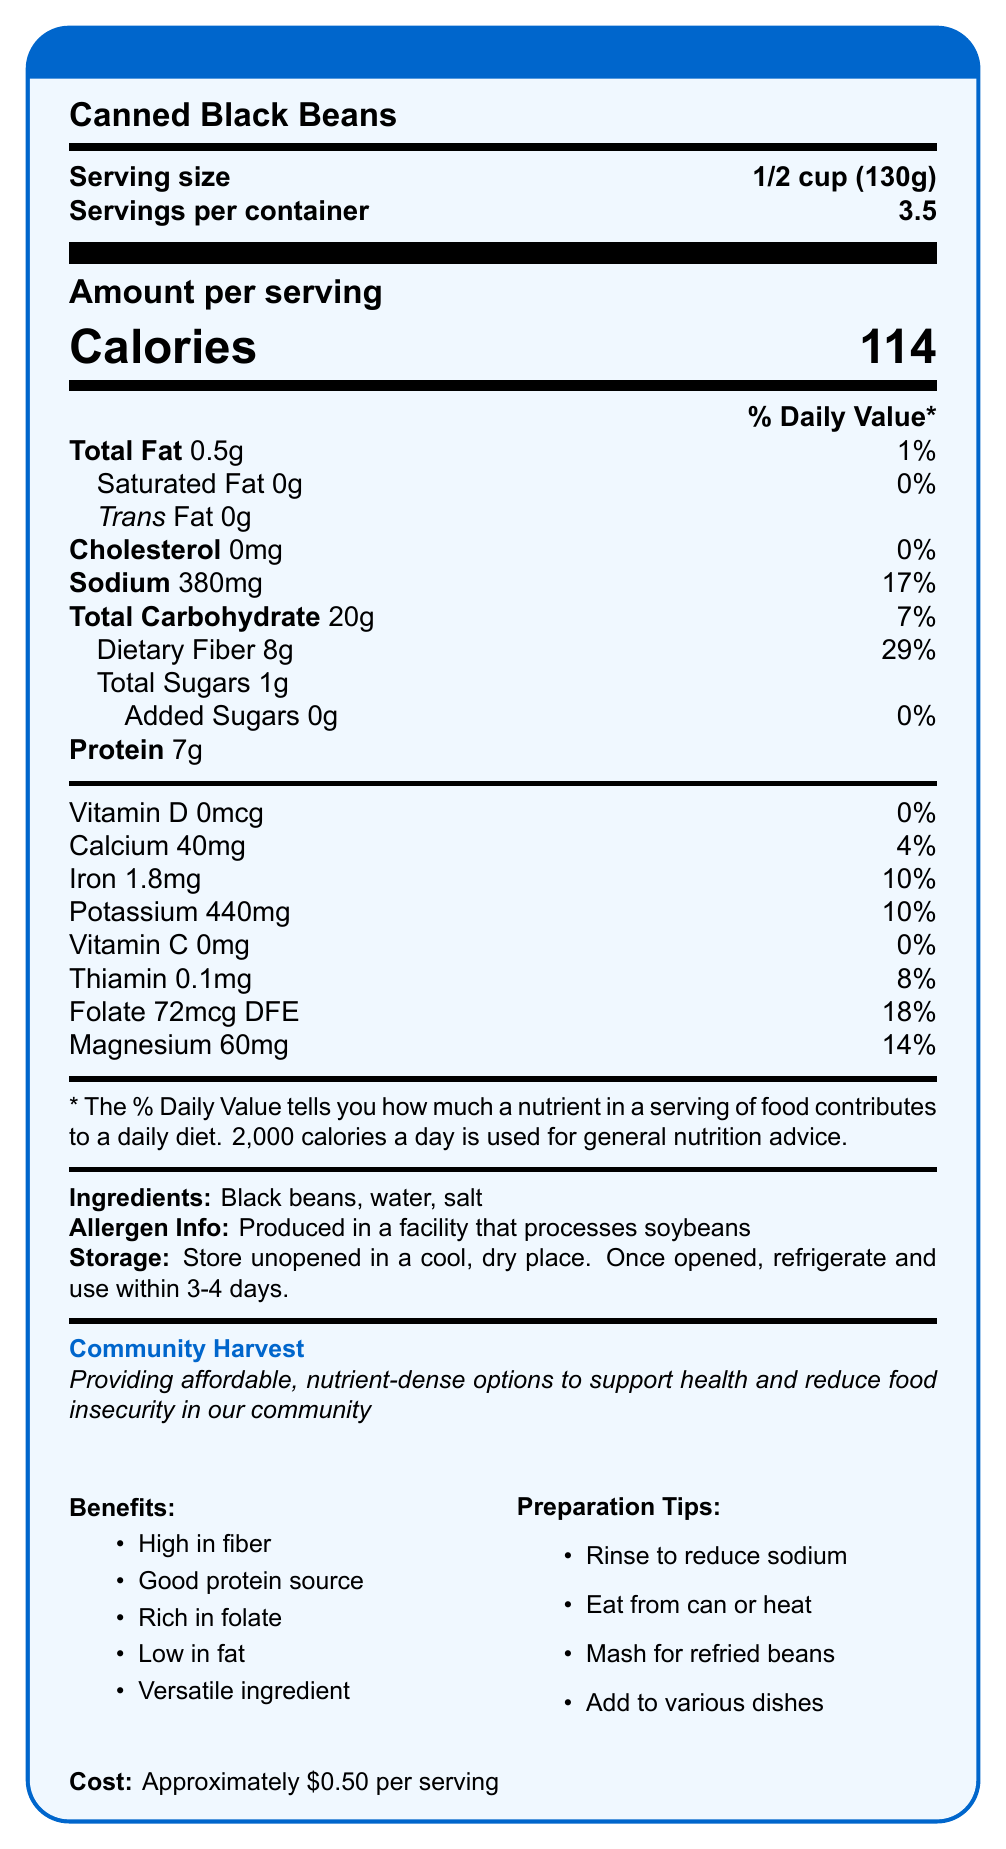What is the serving size of Canned Black Beans? The serving size listed on the document is "1/2 cup (130g)".
Answer: 1/2 cup (130g) How many calories are there per serving? The document states there are 114 calories per serving.
Answer: 114 What percentage of the daily value of dietary fiber is in one serving? The document indicates that one serving provides 29% of the daily value for dietary fiber.
Answer: 29% What are the ingredients in Canned Black Beans? The ingredients listed are black beans, water, and salt.
Answer: Black beans, water, salt What is the brand name of the Canned Black Beans? The brand name mentioned in the document is "Community Harvest".
Answer: Community Harvest How should you store Canned Black Beans once the can is opened? The storage instructions state to refrigerate and use within 3-4 days after opening.
Answer: Refrigerate and use within 3-4 days Does the Canned Black Beans contain any Vitamin D? Yes/No The document states that there is 0mcg of Vitamin D, which is 0% of the daily value.
Answer: No Which of the following nutrients is NOT present in Canned Black Beans? A. Vitamin C B. Calcium C. Iron D. Potassium The document states there is 0mg of Vitamin C (0% daily value).
Answer: A. Vitamin C How much protein does one serving of Canned Black Beans contain? According to the document, one serving contains 7g of protein.
Answer: 7g Which nutrient provides the highest percentage of the daily value in one serving? A. Dietary Fiber B. Sodium C. Folate D. Magnesium Dietary Fiber provides 29% of the daily value per serving, which is the highest percentage compared to other listed nutrients.
Answer: A. Dietary Fiber Is there any added sugar in Canned Black Beans? The document specifies that there are 0g of added sugars.
Answer: No Can you determine the exact cost of one serving from the document? The document provides an approximate cost of \$0.50 per serving, but not the exact cost.
Answer: Approximately \$0.50 Summarize the main nutritional benefits and uses of Canned Black Beans described in the document. The document highlights that Canned Black Beans are high in dietary fiber, provide a good source of plant-based protein, are rich in folate, low in fat, and can be used in various recipes.
Answer: High in fiber, good source of plant-based protein, rich in folate, low in fat, versatile ingredient What impact do Canned Black Beans have on the community according to the document? The document states that Canned Black Beans provide affordable, nutrient-dense options to support health and reduce food insecurity in the community.
Answer: Supports health and reduces food insecurity Can I determine if Canned Black Beans are gluten-free from the information given? The document does not provide information regarding whether Canned Black Beans are gluten-free.
Answer: Not enough information 